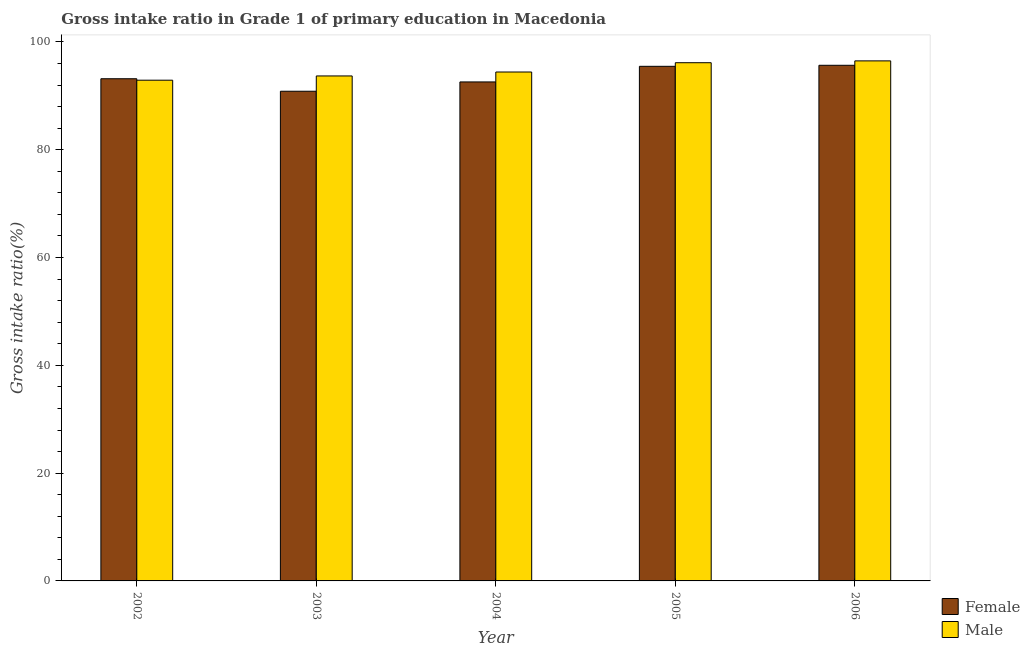Are the number of bars on each tick of the X-axis equal?
Provide a short and direct response. Yes. How many bars are there on the 5th tick from the left?
Your answer should be compact. 2. In how many cases, is the number of bars for a given year not equal to the number of legend labels?
Keep it short and to the point. 0. What is the gross intake ratio(female) in 2004?
Provide a short and direct response. 92.58. Across all years, what is the maximum gross intake ratio(female)?
Keep it short and to the point. 95.67. Across all years, what is the minimum gross intake ratio(female)?
Provide a succinct answer. 90.85. In which year was the gross intake ratio(male) maximum?
Offer a very short reply. 2006. In which year was the gross intake ratio(female) minimum?
Your answer should be compact. 2003. What is the total gross intake ratio(female) in the graph?
Make the answer very short. 467.76. What is the difference between the gross intake ratio(male) in 2003 and that in 2006?
Offer a terse response. -2.79. What is the difference between the gross intake ratio(male) in 2006 and the gross intake ratio(female) in 2003?
Provide a short and direct response. 2.79. What is the average gross intake ratio(female) per year?
Your response must be concise. 93.55. In the year 2006, what is the difference between the gross intake ratio(male) and gross intake ratio(female)?
Provide a short and direct response. 0. In how many years, is the gross intake ratio(female) greater than 80 %?
Ensure brevity in your answer.  5. What is the ratio of the gross intake ratio(female) in 2004 to that in 2006?
Your answer should be very brief. 0.97. Is the difference between the gross intake ratio(male) in 2004 and 2006 greater than the difference between the gross intake ratio(female) in 2004 and 2006?
Make the answer very short. No. What is the difference between the highest and the second highest gross intake ratio(female)?
Make the answer very short. 0.19. What is the difference between the highest and the lowest gross intake ratio(female)?
Offer a terse response. 4.82. In how many years, is the gross intake ratio(female) greater than the average gross intake ratio(female) taken over all years?
Provide a short and direct response. 2. What does the 2nd bar from the left in 2002 represents?
Offer a terse response. Male. Are all the bars in the graph horizontal?
Offer a very short reply. No. How many years are there in the graph?
Your response must be concise. 5. What is the difference between two consecutive major ticks on the Y-axis?
Offer a very short reply. 20. Are the values on the major ticks of Y-axis written in scientific E-notation?
Offer a very short reply. No. Does the graph contain any zero values?
Provide a succinct answer. No. Where does the legend appear in the graph?
Make the answer very short. Bottom right. How are the legend labels stacked?
Your answer should be very brief. Vertical. What is the title of the graph?
Make the answer very short. Gross intake ratio in Grade 1 of primary education in Macedonia. Does "Depositors" appear as one of the legend labels in the graph?
Offer a very short reply. No. What is the label or title of the Y-axis?
Provide a short and direct response. Gross intake ratio(%). What is the Gross intake ratio(%) of Female in 2002?
Your answer should be compact. 93.17. What is the Gross intake ratio(%) of Male in 2002?
Offer a very short reply. 92.9. What is the Gross intake ratio(%) of Female in 2003?
Make the answer very short. 90.85. What is the Gross intake ratio(%) in Male in 2003?
Offer a terse response. 93.69. What is the Gross intake ratio(%) of Female in 2004?
Ensure brevity in your answer.  92.58. What is the Gross intake ratio(%) in Male in 2004?
Provide a short and direct response. 94.42. What is the Gross intake ratio(%) of Female in 2005?
Offer a terse response. 95.48. What is the Gross intake ratio(%) of Male in 2005?
Provide a short and direct response. 96.15. What is the Gross intake ratio(%) in Female in 2006?
Offer a terse response. 95.67. What is the Gross intake ratio(%) of Male in 2006?
Ensure brevity in your answer.  96.49. Across all years, what is the maximum Gross intake ratio(%) in Female?
Give a very brief answer. 95.67. Across all years, what is the maximum Gross intake ratio(%) of Male?
Give a very brief answer. 96.49. Across all years, what is the minimum Gross intake ratio(%) of Female?
Give a very brief answer. 90.85. Across all years, what is the minimum Gross intake ratio(%) of Male?
Offer a terse response. 92.9. What is the total Gross intake ratio(%) in Female in the graph?
Give a very brief answer. 467.76. What is the total Gross intake ratio(%) in Male in the graph?
Give a very brief answer. 473.65. What is the difference between the Gross intake ratio(%) in Female in 2002 and that in 2003?
Make the answer very short. 2.32. What is the difference between the Gross intake ratio(%) of Male in 2002 and that in 2003?
Make the answer very short. -0.79. What is the difference between the Gross intake ratio(%) in Female in 2002 and that in 2004?
Provide a short and direct response. 0.59. What is the difference between the Gross intake ratio(%) in Male in 2002 and that in 2004?
Your answer should be compact. -1.52. What is the difference between the Gross intake ratio(%) in Female in 2002 and that in 2005?
Provide a succinct answer. -2.3. What is the difference between the Gross intake ratio(%) of Male in 2002 and that in 2005?
Provide a succinct answer. -3.25. What is the difference between the Gross intake ratio(%) in Female in 2002 and that in 2006?
Provide a succinct answer. -2.5. What is the difference between the Gross intake ratio(%) of Male in 2002 and that in 2006?
Make the answer very short. -3.59. What is the difference between the Gross intake ratio(%) in Female in 2003 and that in 2004?
Your answer should be compact. -1.73. What is the difference between the Gross intake ratio(%) in Male in 2003 and that in 2004?
Offer a very short reply. -0.73. What is the difference between the Gross intake ratio(%) in Female in 2003 and that in 2005?
Your response must be concise. -4.63. What is the difference between the Gross intake ratio(%) in Male in 2003 and that in 2005?
Give a very brief answer. -2.46. What is the difference between the Gross intake ratio(%) in Female in 2003 and that in 2006?
Your answer should be very brief. -4.82. What is the difference between the Gross intake ratio(%) of Male in 2003 and that in 2006?
Provide a short and direct response. -2.79. What is the difference between the Gross intake ratio(%) in Female in 2004 and that in 2005?
Offer a very short reply. -2.9. What is the difference between the Gross intake ratio(%) of Male in 2004 and that in 2005?
Provide a short and direct response. -1.73. What is the difference between the Gross intake ratio(%) of Female in 2004 and that in 2006?
Provide a succinct answer. -3.09. What is the difference between the Gross intake ratio(%) in Male in 2004 and that in 2006?
Make the answer very short. -2.06. What is the difference between the Gross intake ratio(%) in Female in 2005 and that in 2006?
Your response must be concise. -0.19. What is the difference between the Gross intake ratio(%) of Male in 2005 and that in 2006?
Provide a short and direct response. -0.34. What is the difference between the Gross intake ratio(%) of Female in 2002 and the Gross intake ratio(%) of Male in 2003?
Make the answer very short. -0.52. What is the difference between the Gross intake ratio(%) of Female in 2002 and the Gross intake ratio(%) of Male in 2004?
Provide a short and direct response. -1.25. What is the difference between the Gross intake ratio(%) in Female in 2002 and the Gross intake ratio(%) in Male in 2005?
Keep it short and to the point. -2.97. What is the difference between the Gross intake ratio(%) of Female in 2002 and the Gross intake ratio(%) of Male in 2006?
Your answer should be compact. -3.31. What is the difference between the Gross intake ratio(%) in Female in 2003 and the Gross intake ratio(%) in Male in 2004?
Your response must be concise. -3.57. What is the difference between the Gross intake ratio(%) of Female in 2003 and the Gross intake ratio(%) of Male in 2005?
Your answer should be very brief. -5.3. What is the difference between the Gross intake ratio(%) in Female in 2003 and the Gross intake ratio(%) in Male in 2006?
Your answer should be compact. -5.63. What is the difference between the Gross intake ratio(%) of Female in 2004 and the Gross intake ratio(%) of Male in 2005?
Make the answer very short. -3.57. What is the difference between the Gross intake ratio(%) of Female in 2004 and the Gross intake ratio(%) of Male in 2006?
Provide a succinct answer. -3.91. What is the difference between the Gross intake ratio(%) of Female in 2005 and the Gross intake ratio(%) of Male in 2006?
Your answer should be very brief. -1.01. What is the average Gross intake ratio(%) of Female per year?
Your response must be concise. 93.55. What is the average Gross intake ratio(%) in Male per year?
Offer a terse response. 94.73. In the year 2002, what is the difference between the Gross intake ratio(%) of Female and Gross intake ratio(%) of Male?
Your answer should be very brief. 0.27. In the year 2003, what is the difference between the Gross intake ratio(%) of Female and Gross intake ratio(%) of Male?
Offer a very short reply. -2.84. In the year 2004, what is the difference between the Gross intake ratio(%) in Female and Gross intake ratio(%) in Male?
Make the answer very short. -1.84. In the year 2005, what is the difference between the Gross intake ratio(%) of Female and Gross intake ratio(%) of Male?
Provide a succinct answer. -0.67. In the year 2006, what is the difference between the Gross intake ratio(%) of Female and Gross intake ratio(%) of Male?
Your answer should be compact. -0.82. What is the ratio of the Gross intake ratio(%) of Female in 2002 to that in 2003?
Provide a succinct answer. 1.03. What is the ratio of the Gross intake ratio(%) in Female in 2002 to that in 2004?
Ensure brevity in your answer.  1.01. What is the ratio of the Gross intake ratio(%) of Male in 2002 to that in 2004?
Offer a terse response. 0.98. What is the ratio of the Gross intake ratio(%) in Female in 2002 to that in 2005?
Offer a very short reply. 0.98. What is the ratio of the Gross intake ratio(%) in Male in 2002 to that in 2005?
Make the answer very short. 0.97. What is the ratio of the Gross intake ratio(%) in Female in 2002 to that in 2006?
Offer a very short reply. 0.97. What is the ratio of the Gross intake ratio(%) of Male in 2002 to that in 2006?
Make the answer very short. 0.96. What is the ratio of the Gross intake ratio(%) of Female in 2003 to that in 2004?
Your answer should be compact. 0.98. What is the ratio of the Gross intake ratio(%) in Male in 2003 to that in 2004?
Offer a terse response. 0.99. What is the ratio of the Gross intake ratio(%) in Female in 2003 to that in 2005?
Provide a short and direct response. 0.95. What is the ratio of the Gross intake ratio(%) of Male in 2003 to that in 2005?
Ensure brevity in your answer.  0.97. What is the ratio of the Gross intake ratio(%) in Female in 2003 to that in 2006?
Your answer should be very brief. 0.95. What is the ratio of the Gross intake ratio(%) in Female in 2004 to that in 2005?
Your answer should be very brief. 0.97. What is the ratio of the Gross intake ratio(%) in Male in 2004 to that in 2005?
Give a very brief answer. 0.98. What is the ratio of the Gross intake ratio(%) in Male in 2004 to that in 2006?
Offer a terse response. 0.98. What is the ratio of the Gross intake ratio(%) in Female in 2005 to that in 2006?
Give a very brief answer. 1. What is the ratio of the Gross intake ratio(%) of Male in 2005 to that in 2006?
Give a very brief answer. 1. What is the difference between the highest and the second highest Gross intake ratio(%) of Female?
Keep it short and to the point. 0.19. What is the difference between the highest and the second highest Gross intake ratio(%) in Male?
Your answer should be compact. 0.34. What is the difference between the highest and the lowest Gross intake ratio(%) in Female?
Provide a succinct answer. 4.82. What is the difference between the highest and the lowest Gross intake ratio(%) of Male?
Your response must be concise. 3.59. 